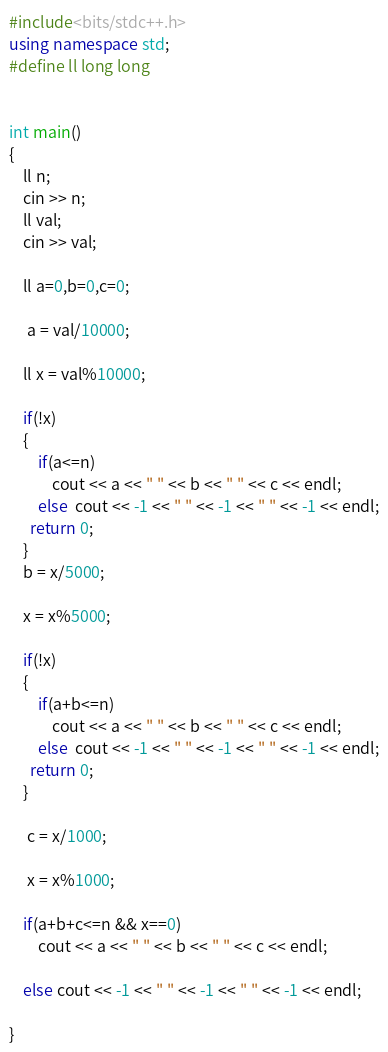Convert code to text. <code><loc_0><loc_0><loc_500><loc_500><_C++_>#include<bits/stdc++.h>
using namespace std;
#define ll long long


int main()
{
    ll n;
    cin >> n;
    ll val;
    cin >> val;

    ll a=0,b=0,c=0;

     a = val/10000;

    ll x = val%10000;

    if(!x)
    {
        if(a<=n)
            cout << a << " " << b << " " << c << endl;
        else  cout << -1 << " " << -1 << " " << -1 << endl;
      return 0;
    }
    b = x/5000;

    x = x%5000;

    if(!x)
    {
        if(a+b<=n)
            cout << a << " " << b << " " << c << endl;
        else  cout << -1 << " " << -1 << " " << -1 << endl;
      return 0;
    }

     c = x/1000;

     x = x%1000;

    if(a+b+c<=n && x==0)
        cout << a << " " << b << " " << c << endl;

    else cout << -1 << " " << -1 << " " << -1 << endl;

}
</code> 